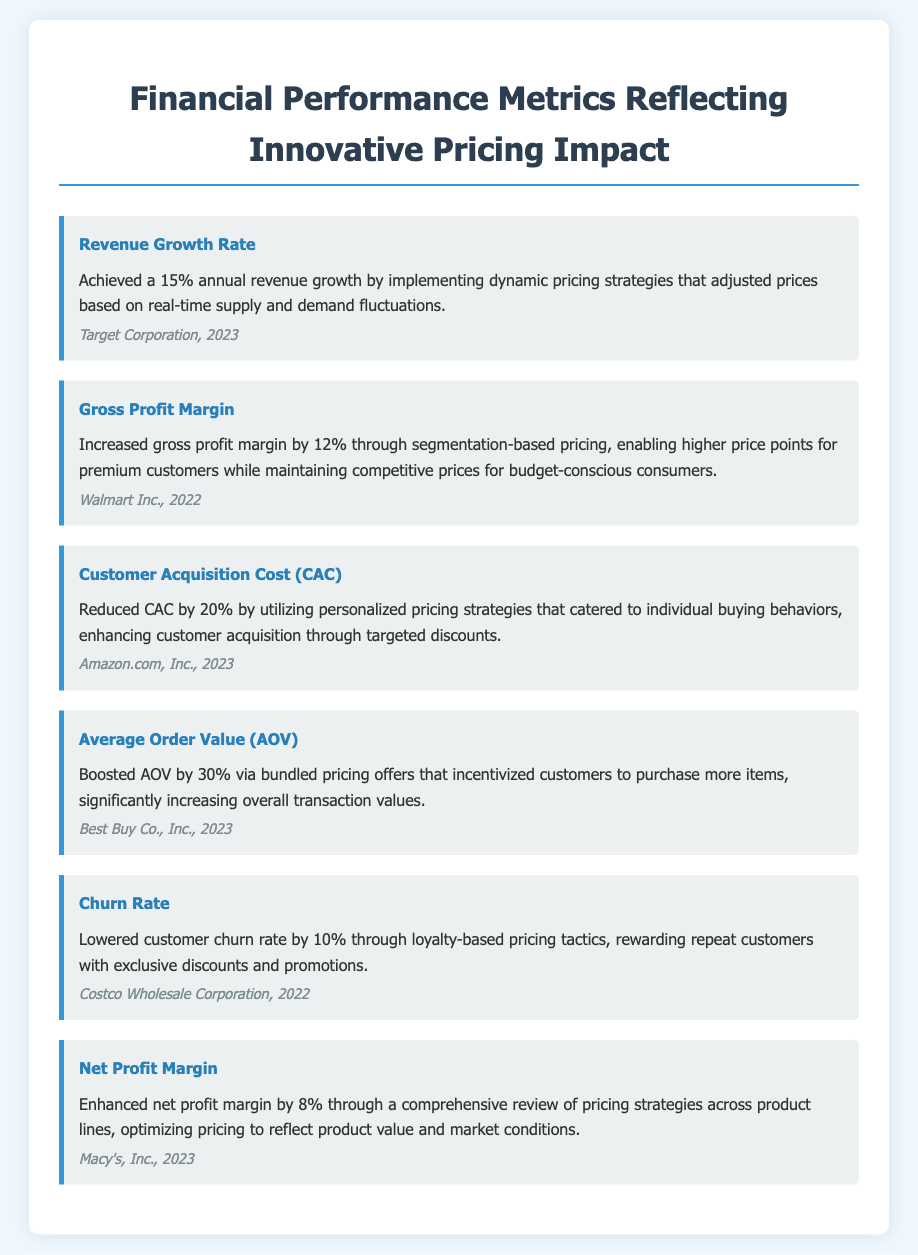What was the revenue growth rate achieved? The revenue growth rate is highlighted as 15% annual revenue growth due to dynamic pricing strategies.
Answer: 15% Which company had a 12% increase in gross profit margin? The company that achieved a 12% increase in gross profit margin through segmentation-based pricing is Walmart Inc.
Answer: Walmart Inc What strategy reduced customer acquisition cost by 20%? The reduction of customer acquisition cost by 20% was achieved through personalized pricing strategies.
Answer: Personalized pricing strategies By what percentage did the average order value increase? The document states that the average order value increased by 30% due to bundled pricing offers.
Answer: 30% Which company implemented loyalty-based pricing that lowered churn rate by 10%? The company that implemented loyalty-based pricing to lower customer churn rate by 10% is Costco Wholesale Corporation.
Answer: Costco Wholesale Corporation What was the enhanced net profit margin percentage achieved by Macy's? The enhanced net profit margin achieved by Macy's through a review of pricing strategies is 8%.
Answer: 8% What type of document is this? The document is a resume focusing on financial performance metrics and innovative pricing impacts.
Answer: Resume What was the impact of dynamic pricing strategies on revenue growth? The impact of dynamic pricing strategies on revenue growth was a 15% annual increase.
Answer: 15% Which pricing strategy incentivized customers to purchase more items? The pricing strategy that incentivized purchasing more items was bundled pricing offers.
Answer: Bundled pricing offers 